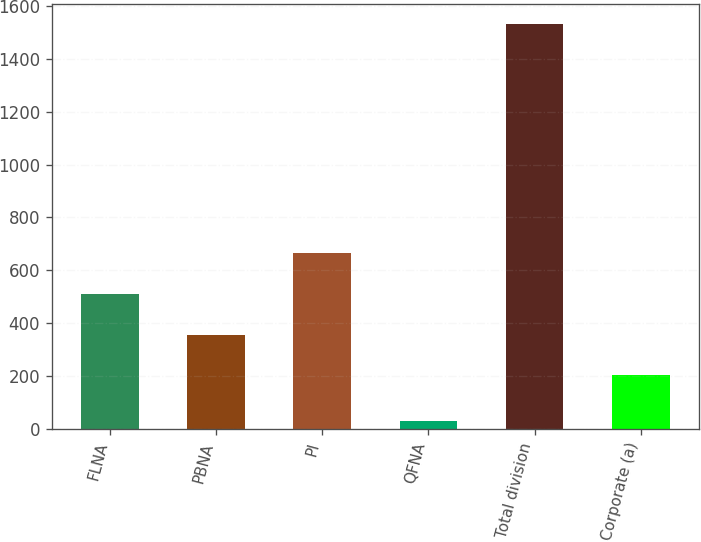Convert chart to OTSL. <chart><loc_0><loc_0><loc_500><loc_500><bar_chart><fcel>FLNA<fcel>PBNA<fcel>PI<fcel>QFNA<fcel>Total division<fcel>Corporate (a)<nl><fcel>512<fcel>355.9<fcel>667<fcel>31<fcel>1530<fcel>206<nl></chart> 